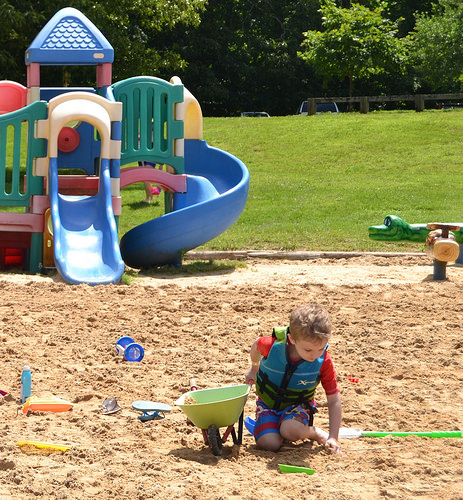<image>
Can you confirm if the sand is in front of the grass? No. The sand is not in front of the grass. The spatial positioning shows a different relationship between these objects. 